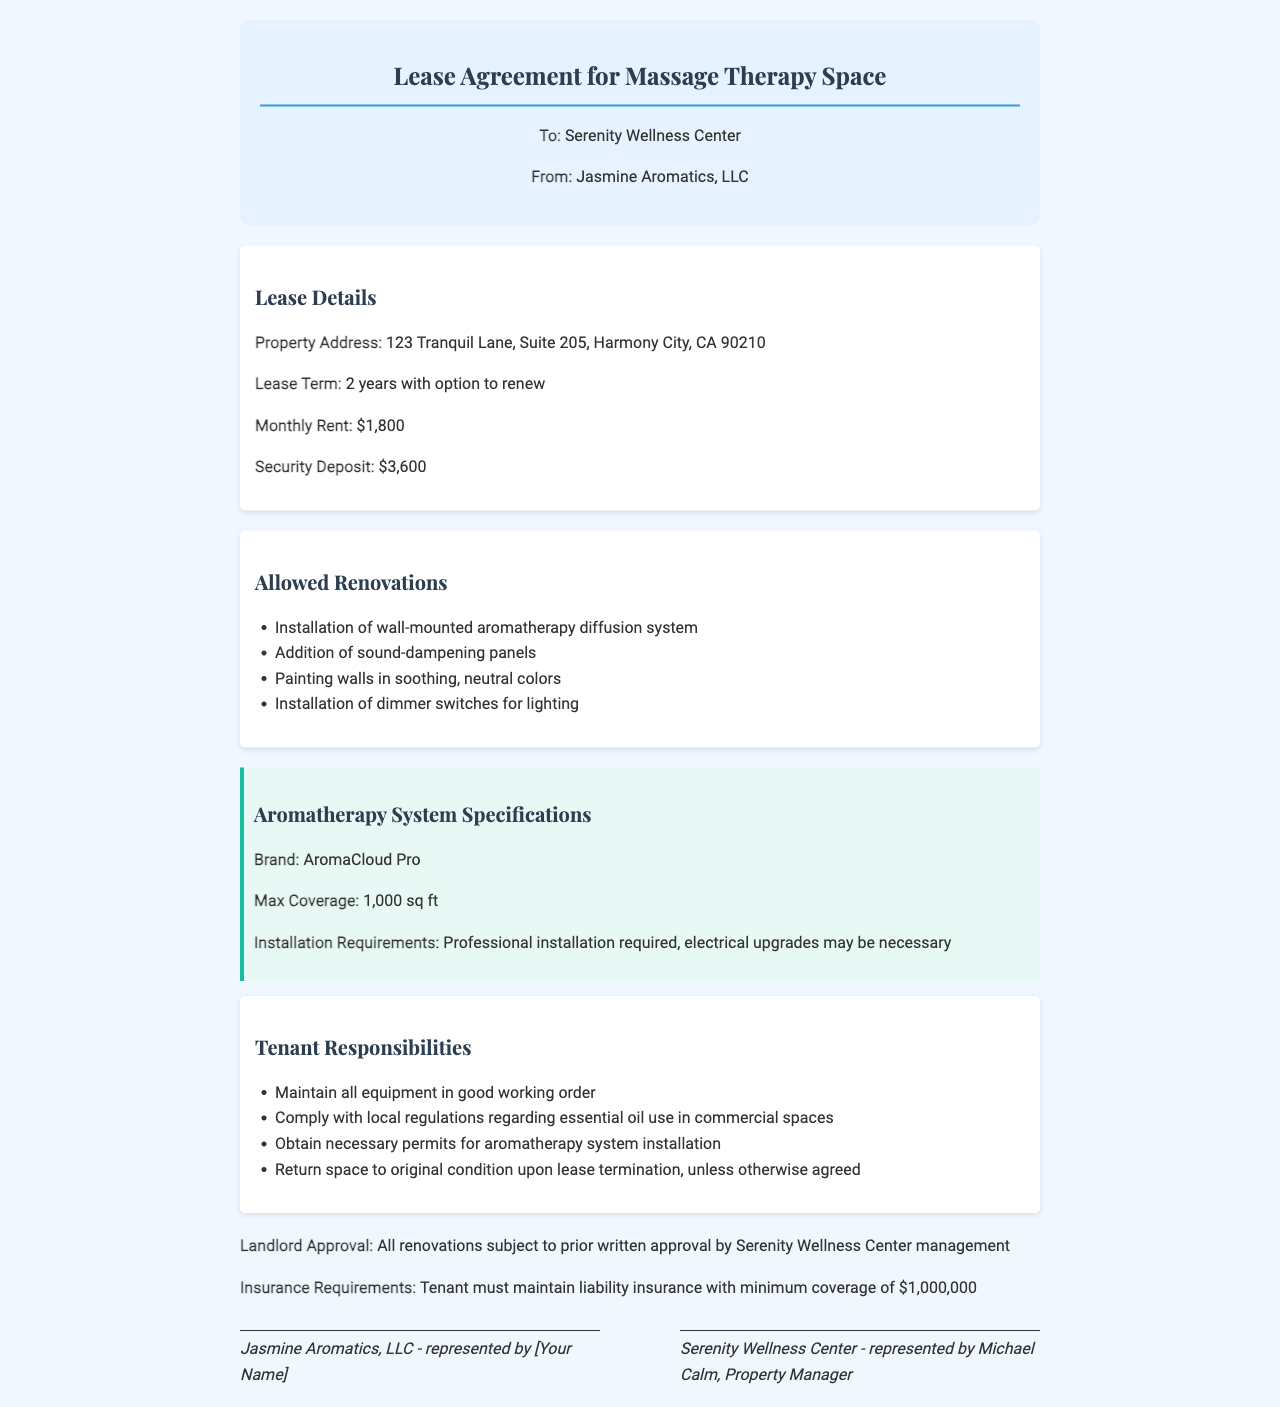what is the property address? The property address is specified in the lease details section of the document, stating "123 Tranquil Lane, Suite 205, Harmony City, CA 90210."
Answer: 123 Tranquil Lane, Suite 205, Harmony City, CA 90210 what is the lease term? The lease term is found in the lease details section, indicating "2 years with option to renew."
Answer: 2 years with option to renew how much is the monthly rent? The monthly rent is mentioned in the lease details section as "$1,800."
Answer: $1,800 what renovations are allowed? The allowed renovations include the installation of an aromatherapy system, which is listed specifically in the renovations section.
Answer: Installation of wall-mounted aromatherapy diffusion system who needs to approve the renovations? The document states that all renovations are subject to prior written approval by Serenity Wellness Center management.
Answer: Serenity Wellness Center management what is the minimum insurance coverage required? The insurance requirements section specifies that the tenant must maintain liability insurance with a minimum coverage of "$1,000,000."
Answer: $1,000,000 why must permits be obtained for the aromatherapy system installation? The reasoning can be inferred from the tenant responsibilities section where it states compliance with local regulations regarding essential oil use in commercial spaces is necessary.
Answer: To comply with local regulations what brand of aromatherapy system is specified? The document identifies the brand of the aromatherapy system in the specifications section as "AromaCloud Pro."
Answer: AromaCloud Pro what is the security deposit amount? The security deposit amount is listed in the lease details section as "$3,600."
Answer: $3,600 